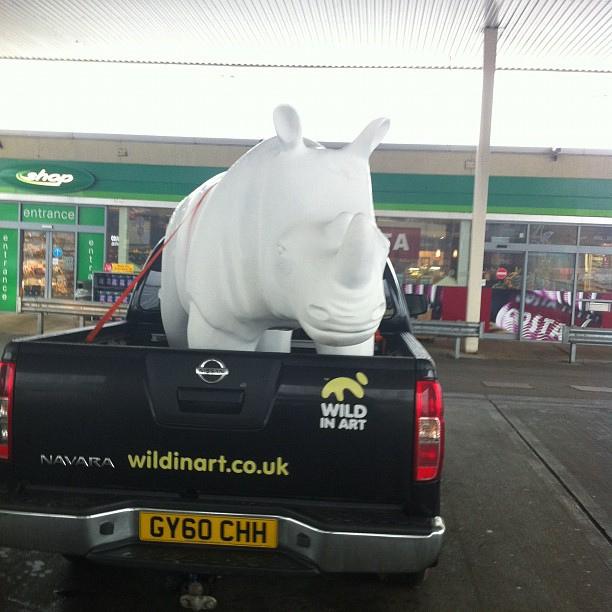What kind of animal is sitting in the back of the truck?
Quick response, please. Rhino. Where is the word entrance?
Quick response, please. Over door. What color is the rhinoceros?
Be succinct. White. 